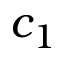<formula> <loc_0><loc_0><loc_500><loc_500>c _ { 1 }</formula> 